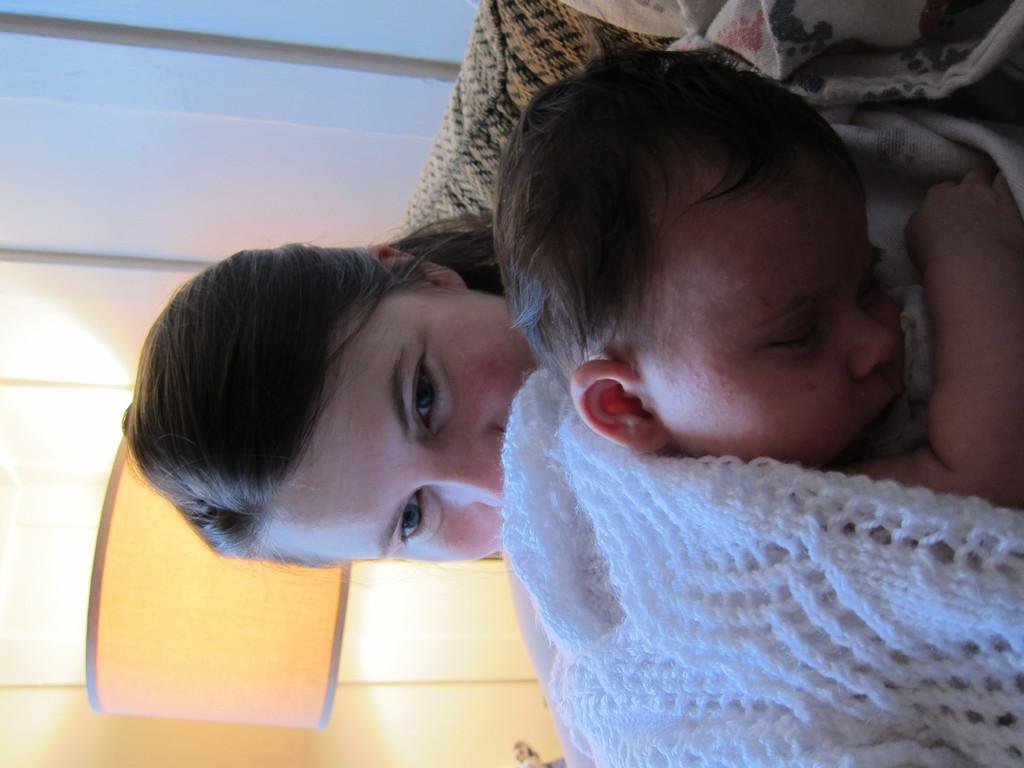How would you summarize this image in a sentence or two? In this image we can see a lady holding a baby. In the background there is a lamp. 